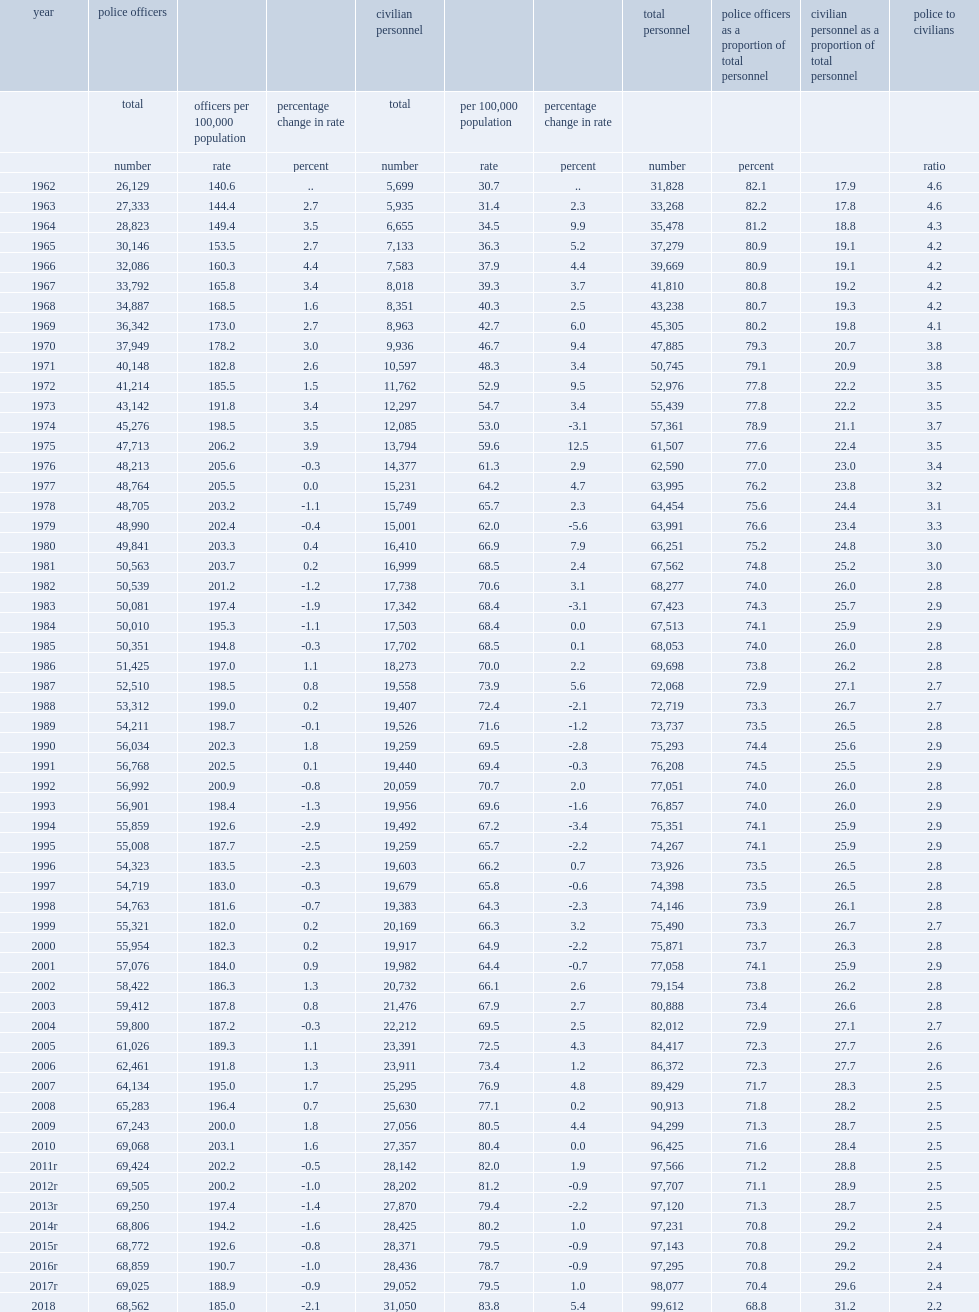How many police offcicers are in canada in 2018? 68562.0. How many police officers are decreased from 2017 to 2018 ? -463. What is the rate of police strength in 2018? 185.0. How many percent of the rate of police strength has declined from 2017 to 2018? 2.1. How many full-time individuals are employed on may 15, 2018, in addition to sworn officers? 31050.0. How many full-time equivalent personnel in these roles are increased from 2017 to 2018? 1998. What is the growth rate of the number of full-time equivalent personnel in these roles from 2017 to 2018? 0.064348. 